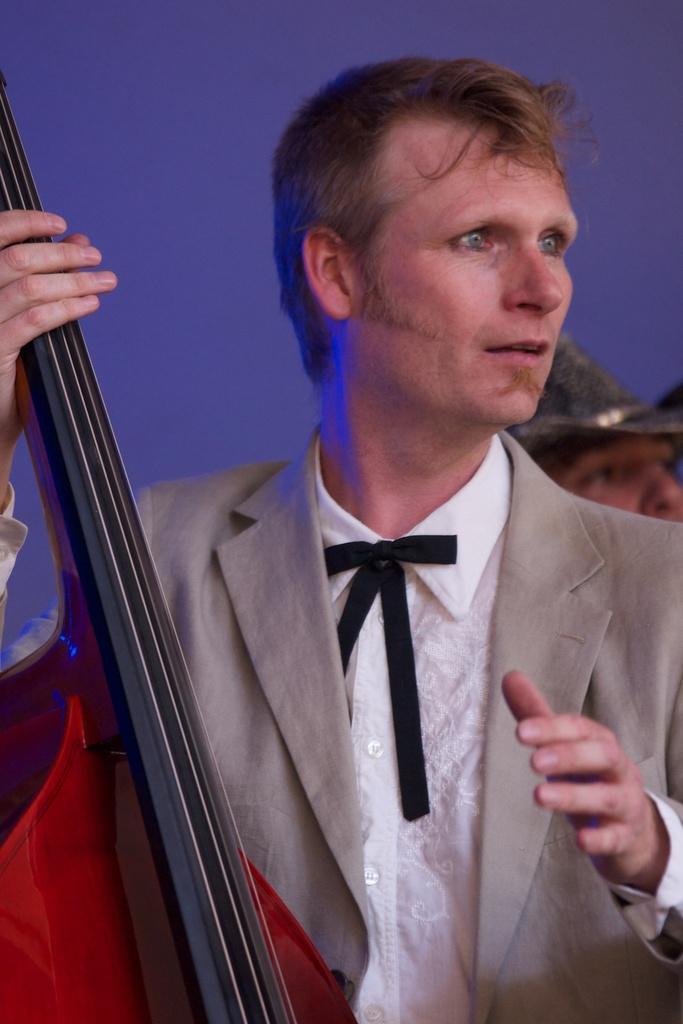Please provide a concise description of this image. In this picture there is a person wearing a suit, he is playing a brass instrument, behind him there is a person wearing hat. The background is blurred. 